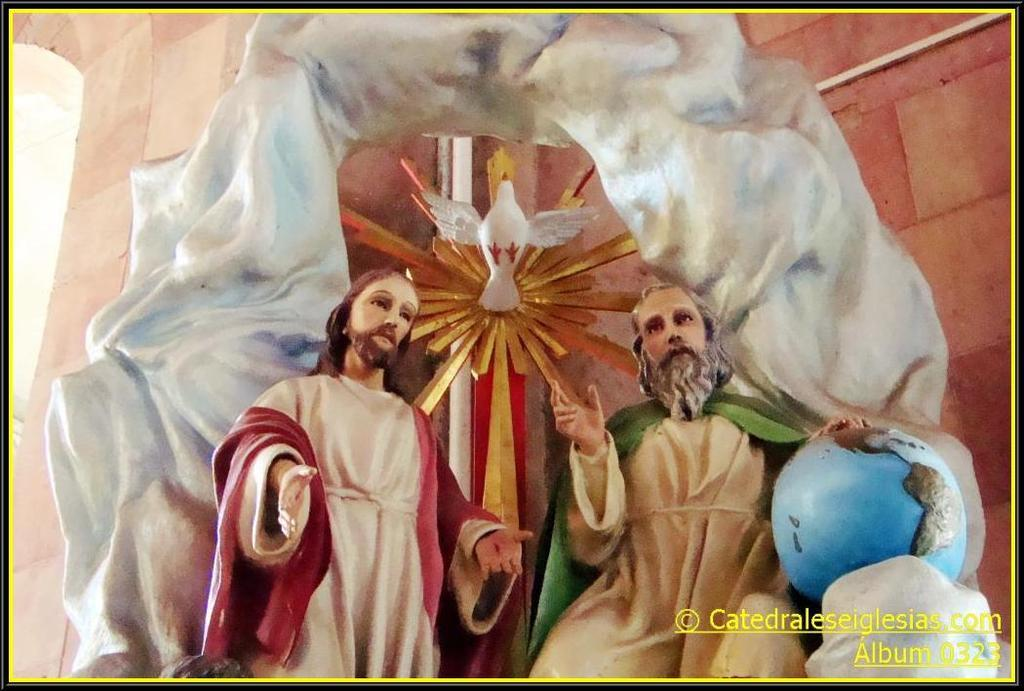What is the main subject of the image? The main subject of the image is a painting. What is depicted in the painting? The painting depicts persons and a bird. What other elements are included in the painting? The painting includes a wall. What can be found at the bottom of the image? There is text at the bottom of the image. Can you tell me how many rats are depicted in the painting? There are no rats depicted in the painting; it features persons, a bird, and a wall. What type of operation is being performed on the persons in the painting? There is no operation being performed on the persons in the painting; they are simply depicted as part of the scene. 